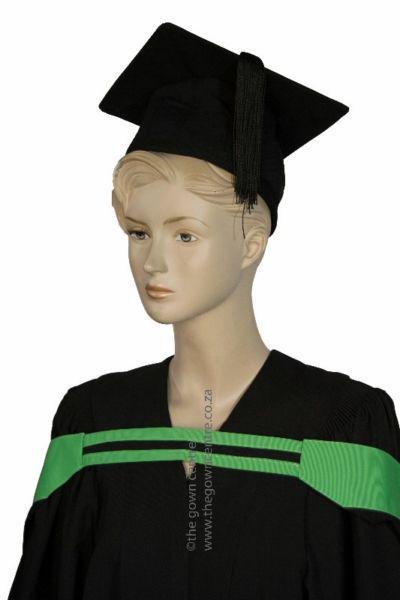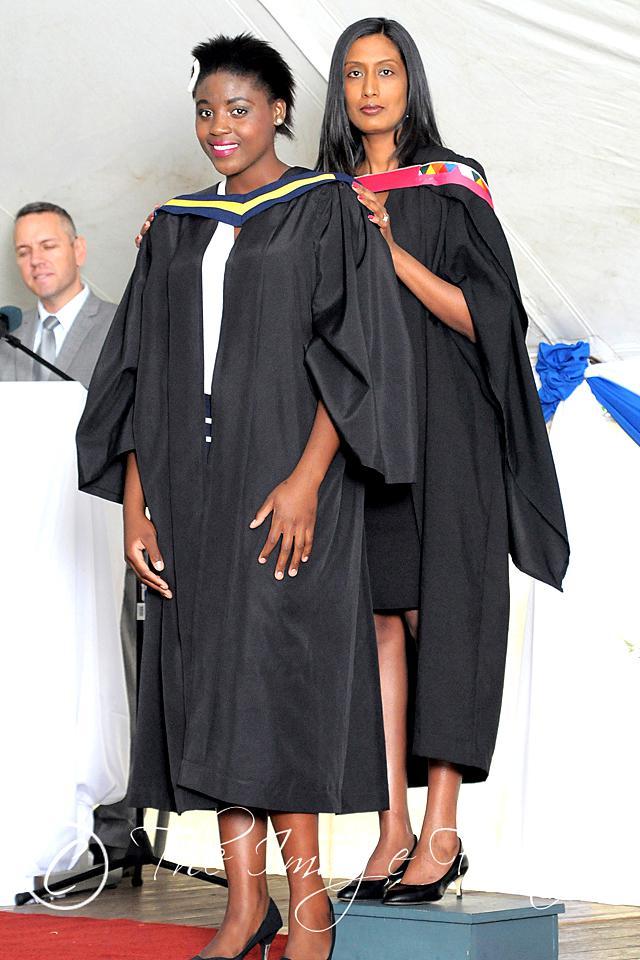The first image is the image on the left, the second image is the image on the right. For the images shown, is this caption "The student in the right image is wearing a purple tie." true? Answer yes or no. No. 